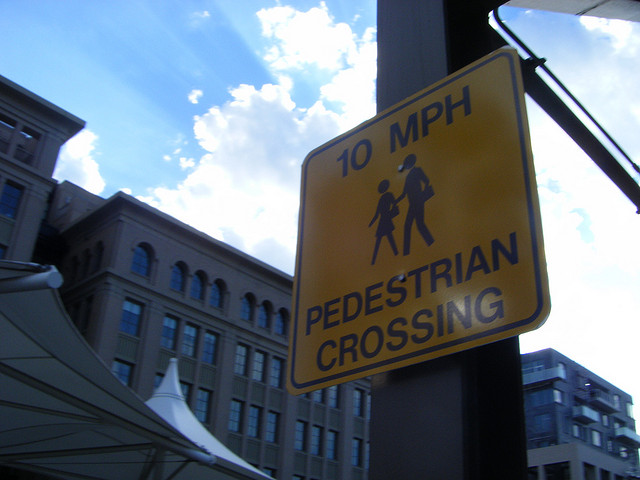Read all the text in this image. 10 MPH PEDESTRIAN CROSSING CROSSING 